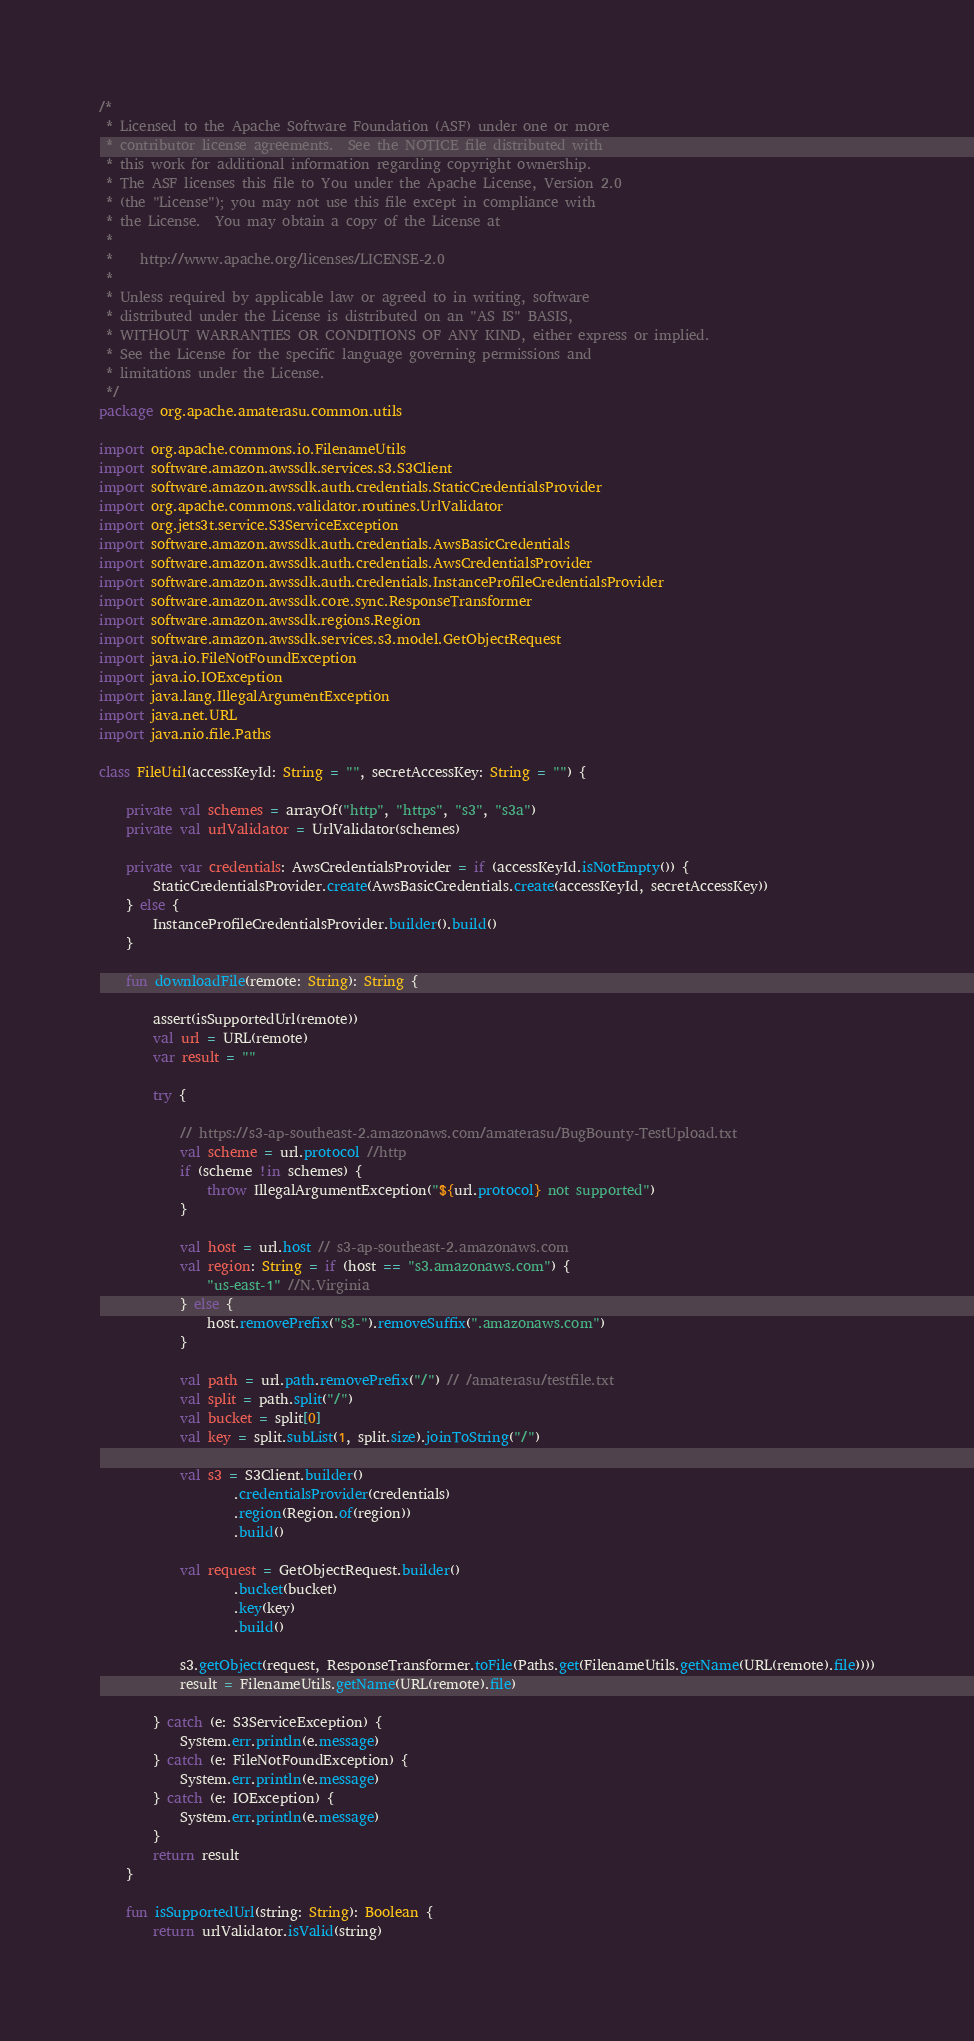<code> <loc_0><loc_0><loc_500><loc_500><_Kotlin_>/*
 * Licensed to the Apache Software Foundation (ASF) under one or more
 * contributor license agreements.  See the NOTICE file distributed with
 * this work for additional information regarding copyright ownership.
 * The ASF licenses this file to You under the Apache License, Version 2.0
 * (the "License"); you may not use this file except in compliance with
 * the License.  You may obtain a copy of the License at
 *
 *    http://www.apache.org/licenses/LICENSE-2.0
 *
 * Unless required by applicable law or agreed to in writing, software
 * distributed under the License is distributed on an "AS IS" BASIS,
 * WITHOUT WARRANTIES OR CONDITIONS OF ANY KIND, either express or implied.
 * See the License for the specific language governing permissions and
 * limitations under the License.
 */
package org.apache.amaterasu.common.utils

import org.apache.commons.io.FilenameUtils
import software.amazon.awssdk.services.s3.S3Client
import software.amazon.awssdk.auth.credentials.StaticCredentialsProvider
import org.apache.commons.validator.routines.UrlValidator
import org.jets3t.service.S3ServiceException
import software.amazon.awssdk.auth.credentials.AwsBasicCredentials
import software.amazon.awssdk.auth.credentials.AwsCredentialsProvider
import software.amazon.awssdk.auth.credentials.InstanceProfileCredentialsProvider
import software.amazon.awssdk.core.sync.ResponseTransformer
import software.amazon.awssdk.regions.Region
import software.amazon.awssdk.services.s3.model.GetObjectRequest
import java.io.FileNotFoundException
import java.io.IOException
import java.lang.IllegalArgumentException
import java.net.URL
import java.nio.file.Paths

class FileUtil(accessKeyId: String = "", secretAccessKey: String = "") {

    private val schemes = arrayOf("http", "https", "s3", "s3a")
    private val urlValidator = UrlValidator(schemes)

    private var credentials: AwsCredentialsProvider = if (accessKeyId.isNotEmpty()) {
        StaticCredentialsProvider.create(AwsBasicCredentials.create(accessKeyId, secretAccessKey))
    } else {
        InstanceProfileCredentialsProvider.builder().build()
    }

    fun downloadFile(remote: String): String {

        assert(isSupportedUrl(remote))
        val url = URL(remote)
        var result = ""

        try {

            // https://s3-ap-southeast-2.amazonaws.com/amaterasu/BugBounty-TestUpload.txt
            val scheme = url.protocol //http
            if (scheme !in schemes) {
                throw IllegalArgumentException("${url.protocol} not supported")
            }

            val host = url.host // s3-ap-southeast-2.amazonaws.com
            val region: String = if (host == "s3.amazonaws.com") {
                "us-east-1" //N.Virginia
            } else {
                host.removePrefix("s3-").removeSuffix(".amazonaws.com")
            }

            val path = url.path.removePrefix("/") // /amaterasu/testfile.txt
            val split = path.split("/")
            val bucket = split[0]
            val key = split.subList(1, split.size).joinToString("/")

            val s3 = S3Client.builder()
                    .credentialsProvider(credentials)
                    .region(Region.of(region))
                    .build()

            val request = GetObjectRequest.builder()
                    .bucket(bucket)
                    .key(key)
                    .build()

            s3.getObject(request, ResponseTransformer.toFile(Paths.get(FilenameUtils.getName(URL(remote).file))))
            result = FilenameUtils.getName(URL(remote).file)

        } catch (e: S3ServiceException) {
            System.err.println(e.message)
        } catch (e: FileNotFoundException) {
            System.err.println(e.message)
        } catch (e: IOException) {
            System.err.println(e.message)
        }
        return result
    }

    fun isSupportedUrl(string: String): Boolean {
        return urlValidator.isValid(string)</code> 